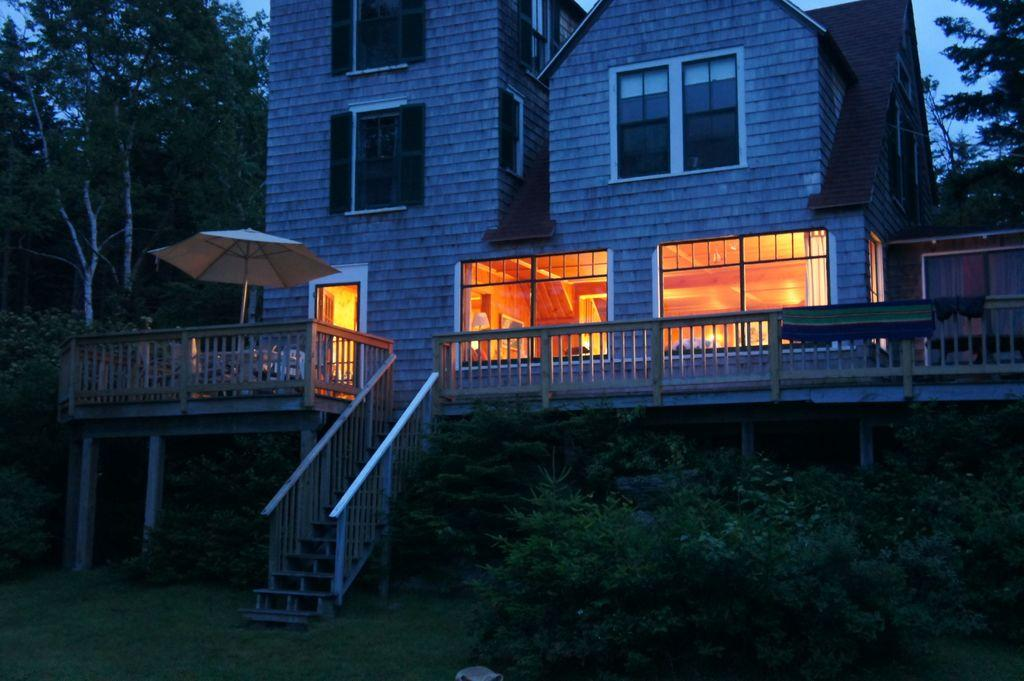What type of structure is visible in the image? There is a house in the image. How is the house positioned in relation to the surrounding environment? The house is situated between trees. What object can be seen on the left side of the image? There is an umbrella on the left side of the image. What architectural feature is present in the image? There is a staircase in the image. What type of vegetation is visible at the bottom of the image? There are plants at the bottom of the image. What month is it in the image? The month cannot be determined from the image, as there is no information about the time of year or season. 